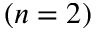<formula> <loc_0><loc_0><loc_500><loc_500>( n = 2 )</formula> 